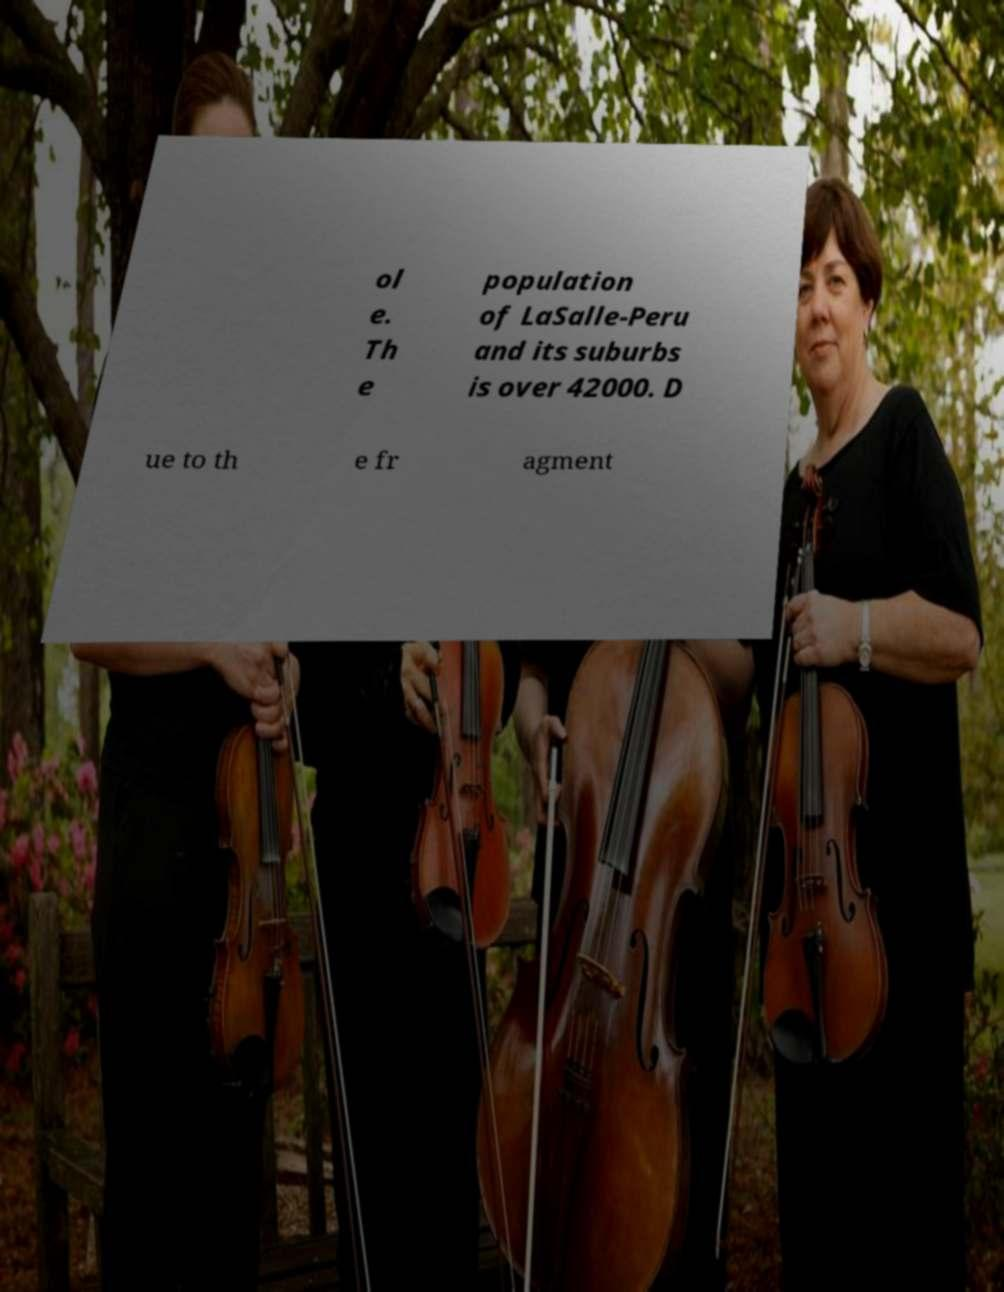Can you accurately transcribe the text from the provided image for me? ol e. Th e population of LaSalle-Peru and its suburbs is over 42000. D ue to th e fr agment 